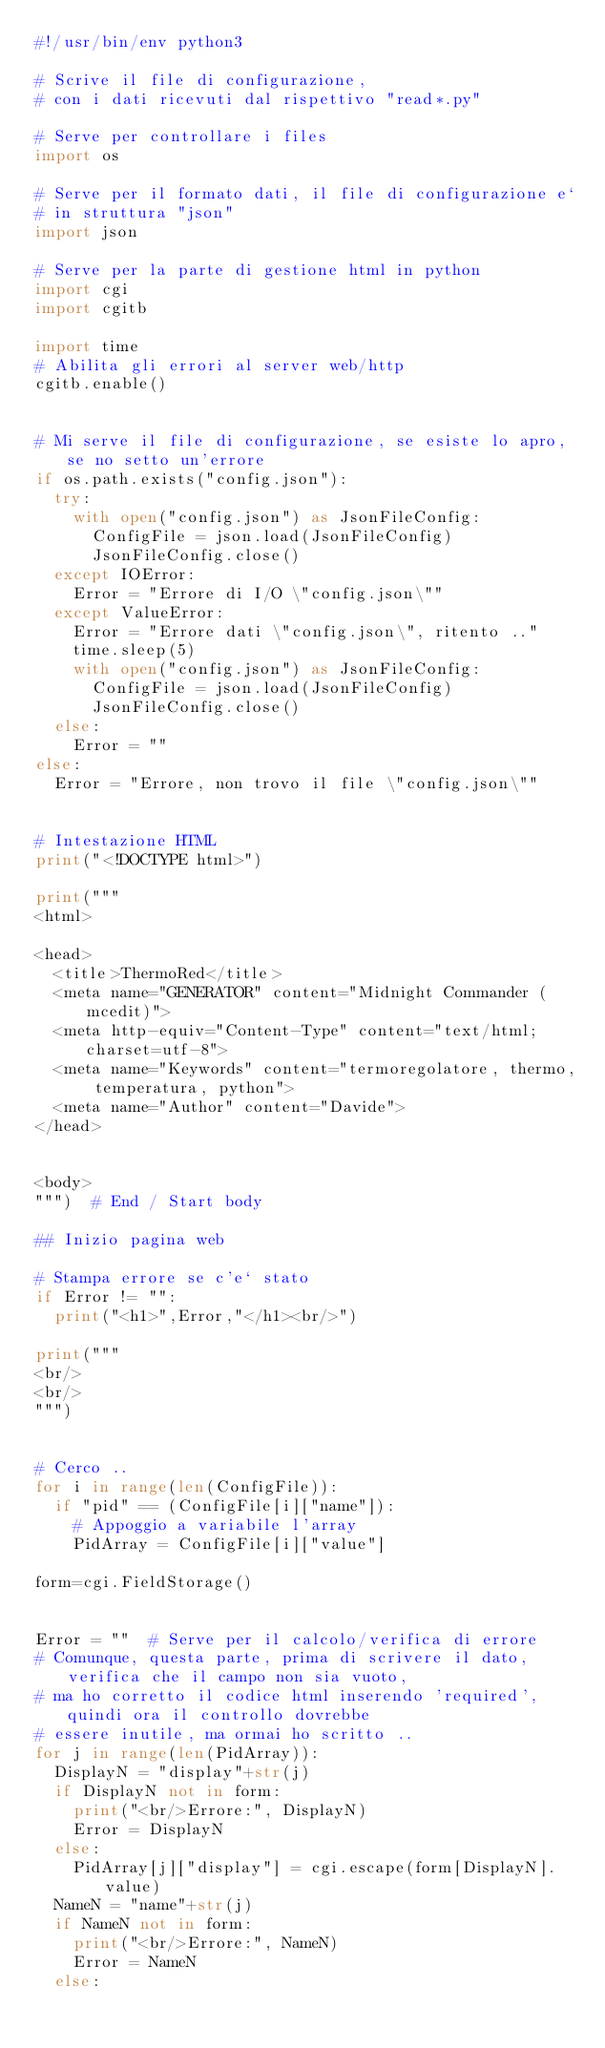Convert code to text. <code><loc_0><loc_0><loc_500><loc_500><_Python_>#!/usr/bin/env python3

# Scrive il file di configurazione,
# con i dati ricevuti dal rispettivo "read*.py"

# Serve per controllare i files
import os

# Serve per il formato dati, il file di configurazione e`
# in struttura "json"
import json

# Serve per la parte di gestione html in python
import cgi
import cgitb

import time
# Abilita gli errori al server web/http
cgitb.enable()


# Mi serve il file di configurazione, se esiste lo apro, se no setto un'errore
if os.path.exists("config.json"):
	try:
		with open("config.json") as JsonFileConfig:
			ConfigFile = json.load(JsonFileConfig)
			JsonFileConfig.close()
	except IOError:
		Error = "Errore di I/O \"config.json\""
	except ValueError:
		Error = "Errore dati \"config.json\", ritento .."
		time.sleep(5)
		with open("config.json") as JsonFileConfig:
			ConfigFile = json.load(JsonFileConfig)
			JsonFileConfig.close()
	else:
		Error = ""
else:
	Error = "Errore, non trovo il file \"config.json\""


# Intestazione HTML
print("<!DOCTYPE html>")

print("""
<html>

<head>
  <title>ThermoRed</title>
  <meta name="GENERATOR" content="Midnight Commander (mcedit)">
  <meta http-equiv="Content-Type" content="text/html; charset=utf-8">
  <meta name="Keywords" content="termoregolatore, thermo, temperatura, python">
  <meta name="Author" content="Davide">
</head>


<body>
""")	# End / Start body

## Inizio pagina web

# Stampa errore se c'e` stato
if Error != "":
	print("<h1>",Error,"</h1><br/>")

print("""
<br/>
<br/>
""")


# Cerco ..
for i in range(len(ConfigFile)):
	if "pid" == (ConfigFile[i]["name"]):
		# Appoggio a variabile l'array
		PidArray = ConfigFile[i]["value"]

form=cgi.FieldStorage()


Error = ""	# Serve per il calcolo/verifica di errore
# Comunque, questa parte, prima di scrivere il dato, verifica che il campo non sia vuoto,
# ma ho corretto il codice html inserendo 'required', quindi ora il controllo dovrebbe
# essere inutile, ma ormai ho scritto ..
for j in range(len(PidArray)):
	DisplayN = "display"+str(j)
	if DisplayN not in form:
		print("<br/>Errore:", DisplayN)
		Error = DisplayN
	else:
		PidArray[j]["display"] = cgi.escape(form[DisplayN].value)
	NameN = "name"+str(j)
	if NameN not in form:
		print("<br/>Errore:", NameN)
		Error = NameN
	else:</code> 